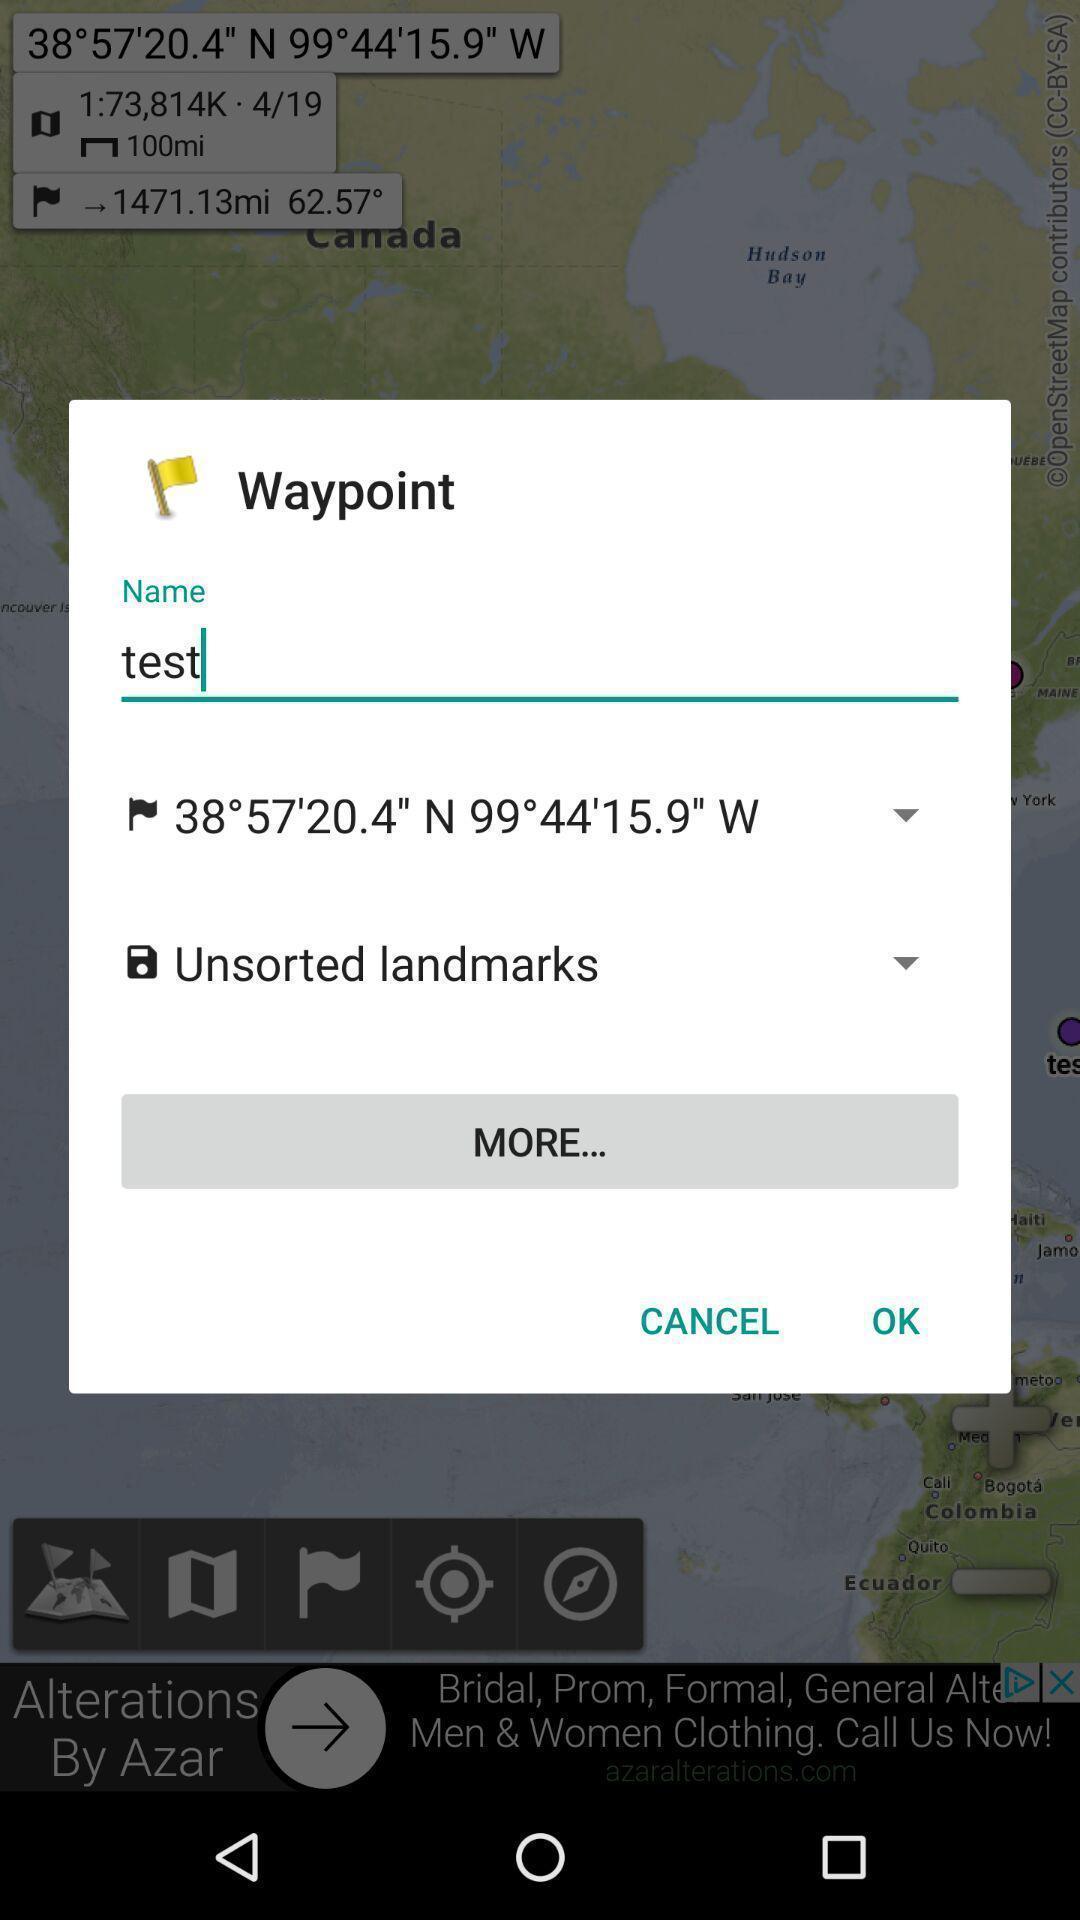Give me a summary of this screen capture. Pop-up is having a input box to find location details. 